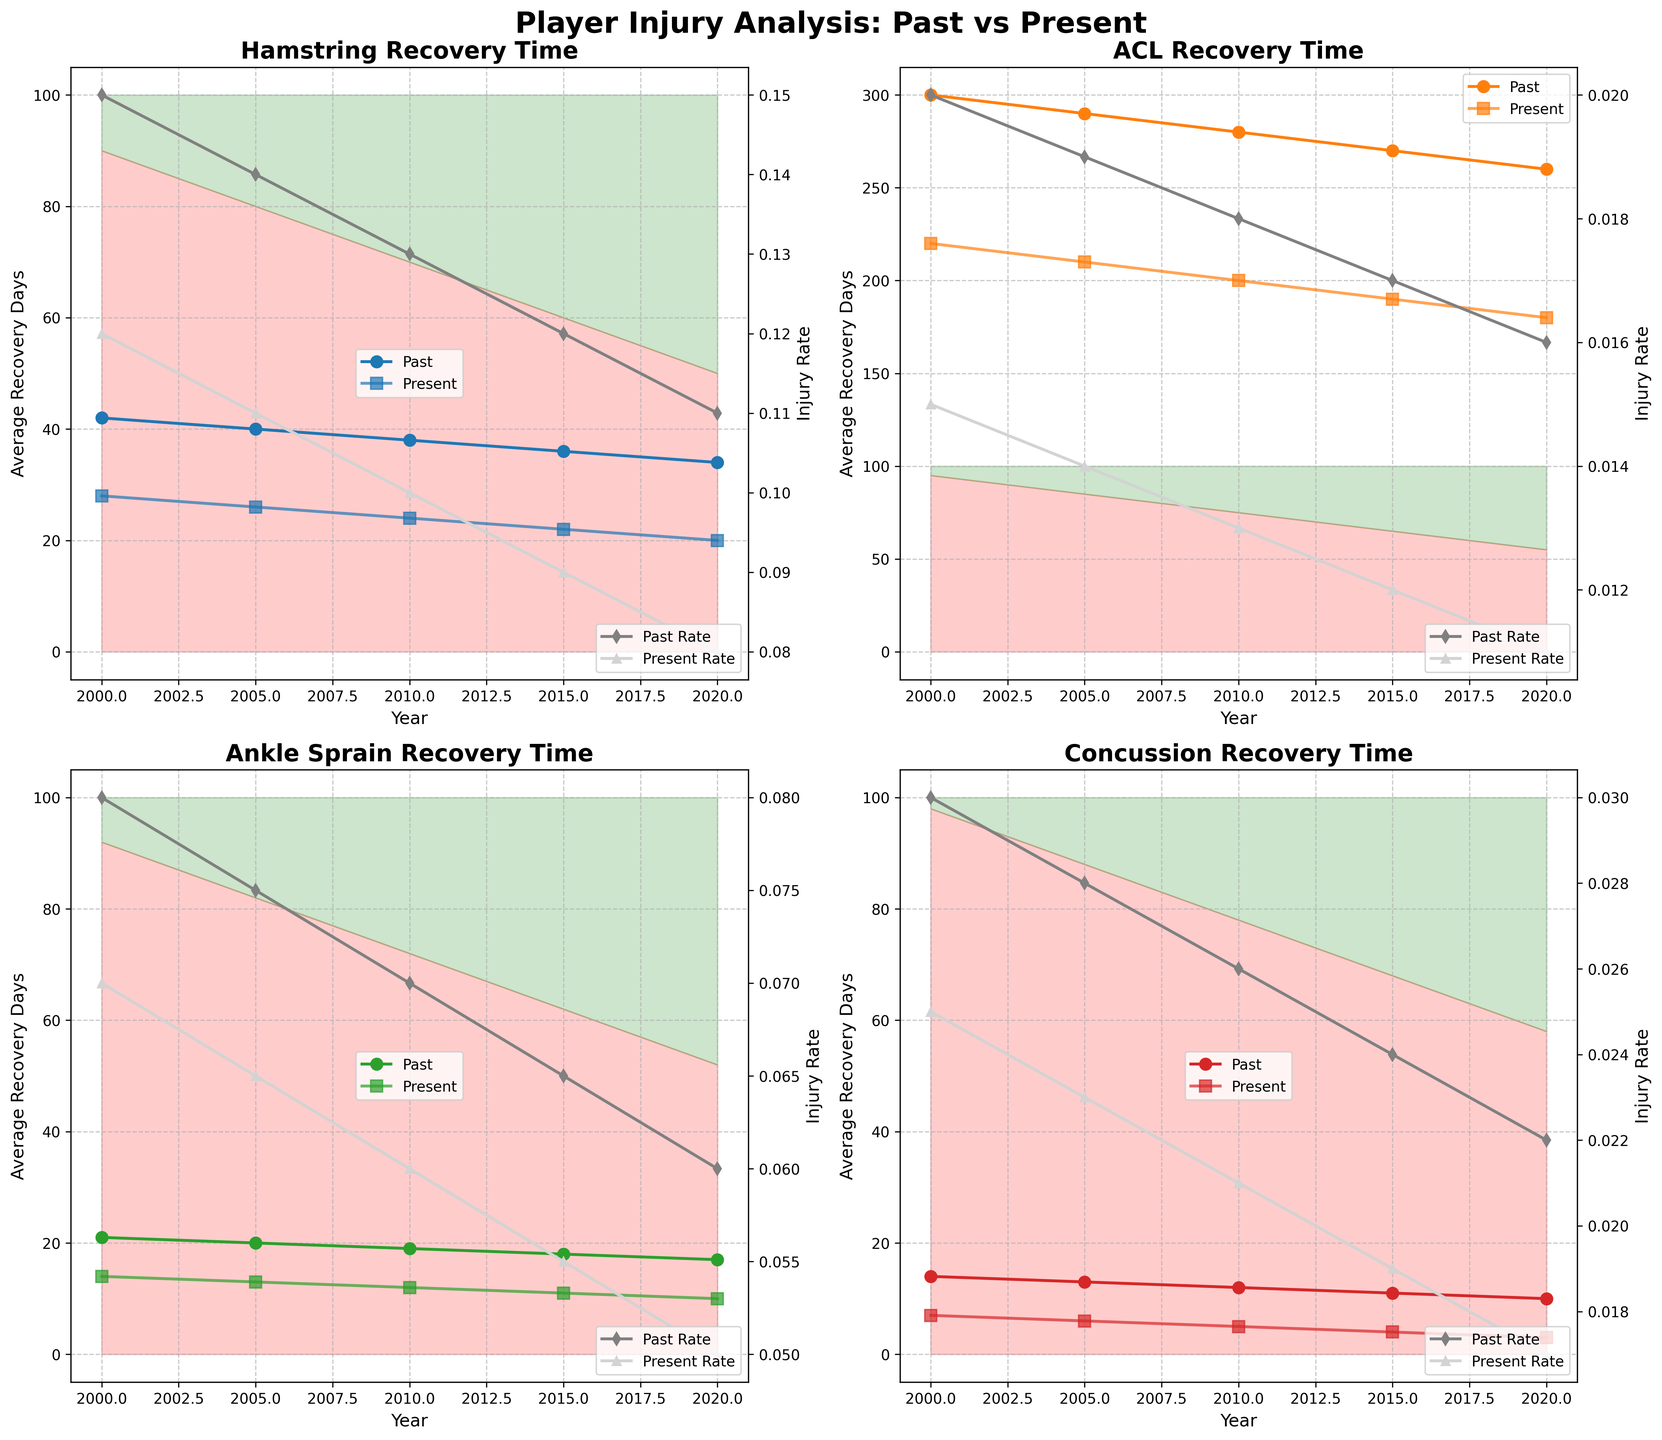How have the average recovery days for Hamstring injuries changed from 2000 to 2020? To find this, look at the line plot for Hamstring injuries. The plot shows a decrease in recovery days from 42 days in 2000 to 20 days in 2020.
Answer: Decreased by 22 days By what percentage did modern treatment approaches increase for ACL injuries from 2000 to 2020? To determine the increase, check the shaded fill areas representing modern treatment for ACL injuries. Modern treatment increased from 5% in 2000 to 45% in 2020. The percentage increase is (45% - 5%) = 40%.
Answer: 40% Compare the injury rates of Concussion injuries between 2000 and 2020. Which year had a lower rate and by how much? Look at the gray and light gray lines representing injury rates for past and present conditions. In 2000, the concussion injury rate was 0.03, and in 2020, it was 0.017. The difference is 0.03 - 0.017 = 0.013.
Answer: 2020, by 0.013 Which injury type saw the largest decrease in average recovery days from the past to the present in 2020? Examine the endpoints of the 'past' and 'present' recovery day lines for each injury. The ACL injury saw the largest decrease from 300 days to 180 days, a reduction of 120 days.
Answer: ACL How do the trends in traditional vs. modern treatment approaches for Ankle Sprains compare between 2000 and 2020? Observe the shaded areas below and above the lines for traditional (red) and modern (green) treatments regarding Ankle Sprains. Traditional treatment declined from 92% to 52%, while modern treatment rose from 8% to 48%.
Answer: Traditional decreased, Modern increased What is the difference in average recovery days for Concussion injuries between 2000 and 2020, and what can you infer about treatment effectiveness? Concussion recovery days fell from 14 days in 2000 to 3 days in 2020, a difference of 11 days. This suggests that modern treatments may be more effective.
Answer: Decreased by 11 days, indicating improved effectiveness Calculate the percentage decrease in recovery days for Ankle Sprains between 2000 and 2020. For Ankle Sprains, recovery days fell from 21 in 2000 to 10 in 2020. The percentage decrease is calculated as [(21 - 10) / 21] * 100 ≈ 52.38%.
Answer: 52.38% In which year did the past injury rate of Hamstring injuries first fall below 0.13? Observe the gray line for the past injury rate of Hamstring. The injury rate fell below 0.13 in 2010.
Answer: 2010 How does the trend in recovery times for Hamstring injuries illustrate the impact of modern treatments over time? By comparing the slope of the 'present' recovery line, which shows a steeper decline compared to the 'past', we see that recovery times improved significantly as modern treatments became more prevalent. This indicates the positive impact of modern treatments on recovery times.
Answer: Steeper decline in recovery times due to modern treatments 